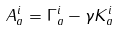<formula> <loc_0><loc_0><loc_500><loc_500>A _ { a } ^ { i } = \Gamma _ { a } ^ { i } - \gamma K _ { a } ^ { i }</formula> 